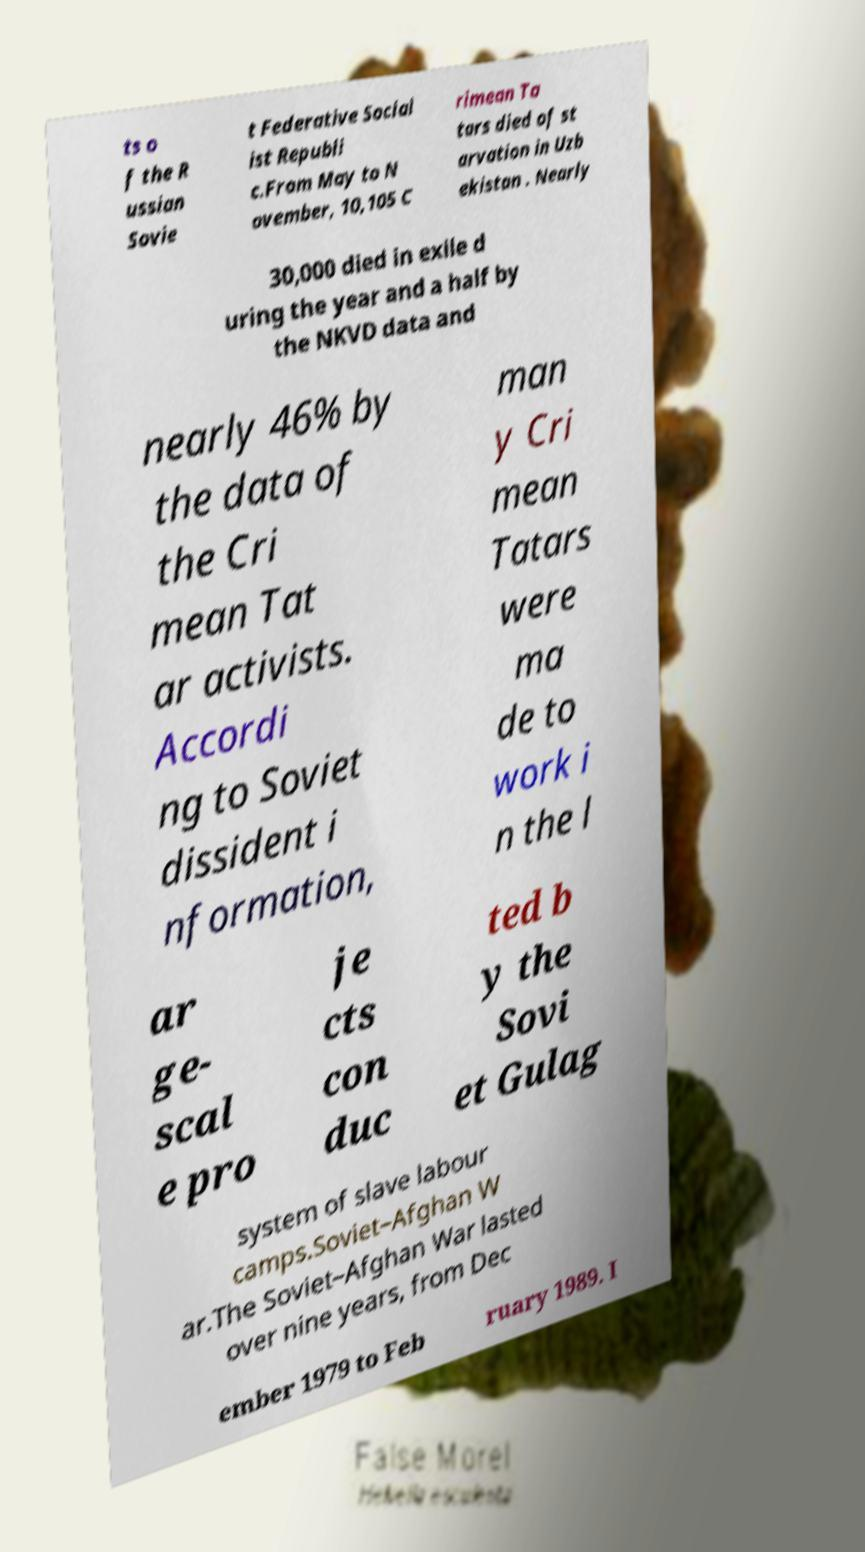Can you accurately transcribe the text from the provided image for me? ts o f the R ussian Sovie t Federative Social ist Republi c.From May to N ovember, 10,105 C rimean Ta tars died of st arvation in Uzb ekistan . Nearly 30,000 died in exile d uring the year and a half by the NKVD data and nearly 46% by the data of the Cri mean Tat ar activists. Accordi ng to Soviet dissident i nformation, man y Cri mean Tatars were ma de to work i n the l ar ge- scal e pro je cts con duc ted b y the Sovi et Gulag system of slave labour camps.Soviet–Afghan W ar.The Soviet–Afghan War lasted over nine years, from Dec ember 1979 to Feb ruary 1989. I 